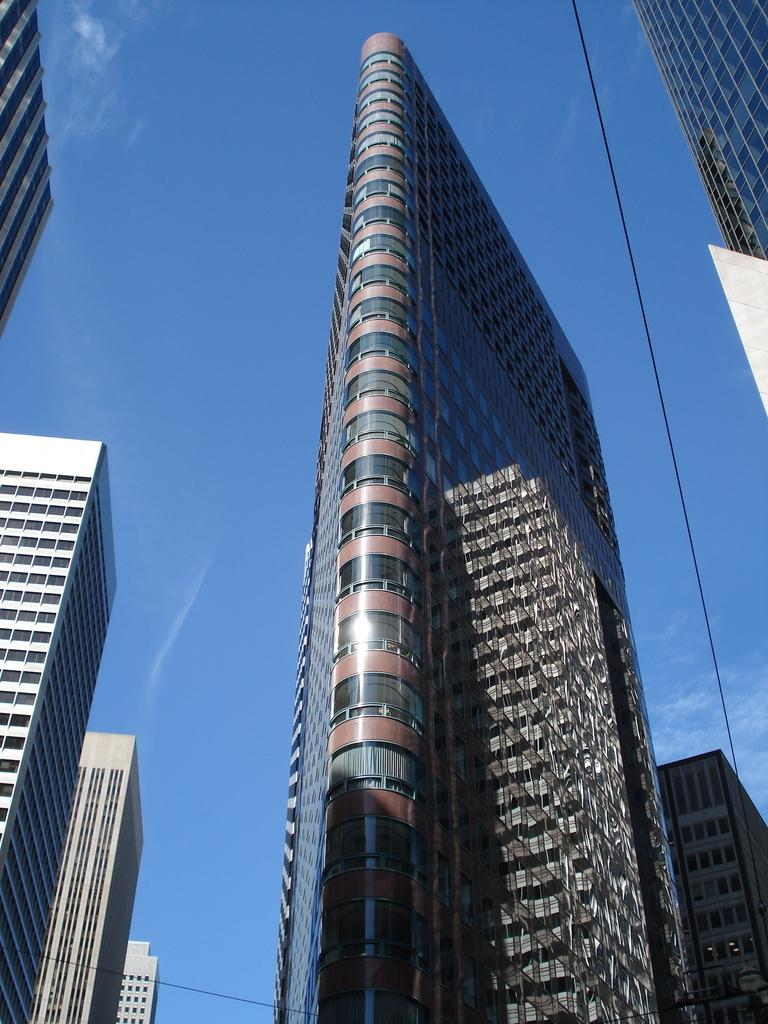What type of structures can be seen in the image? There are buildings in the image. What else is visible in the image besides the buildings? Cables are present in the image. What can be seen in the background of the image? There is a sky visible in the image. What type of drug can be seen in the image? There is no drug present in the image. What type of machine is visible in the image? There is no machine visible in the image. 